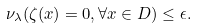<formula> <loc_0><loc_0><loc_500><loc_500>\nu _ { \lambda } ( \zeta ( x ) = 0 , \forall x \in D ) \leq \epsilon .</formula> 